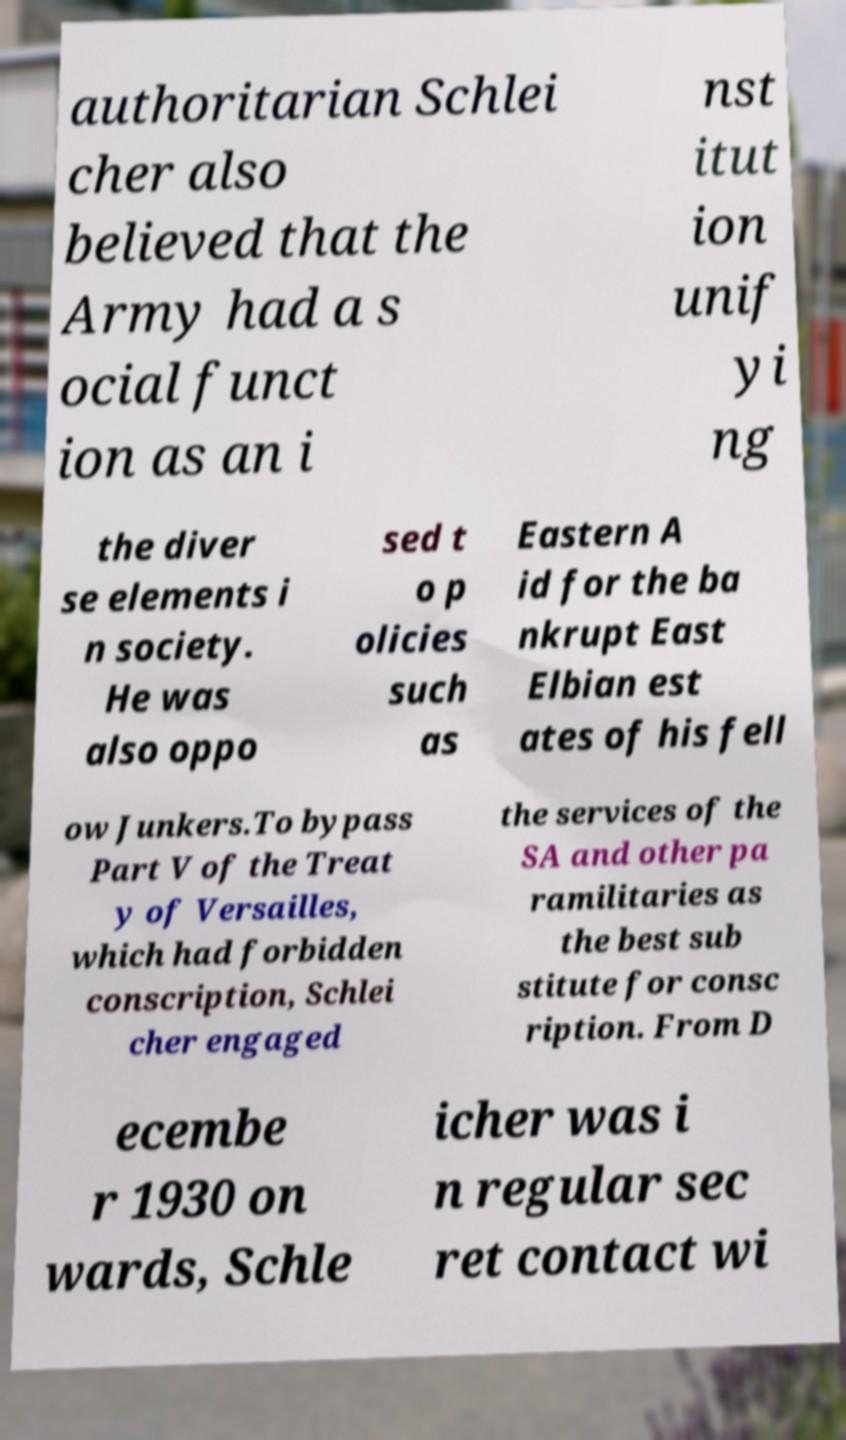There's text embedded in this image that I need extracted. Can you transcribe it verbatim? authoritarian Schlei cher also believed that the Army had a s ocial funct ion as an i nst itut ion unif yi ng the diver se elements i n society. He was also oppo sed t o p olicies such as Eastern A id for the ba nkrupt East Elbian est ates of his fell ow Junkers.To bypass Part V of the Treat y of Versailles, which had forbidden conscription, Schlei cher engaged the services of the SA and other pa ramilitaries as the best sub stitute for consc ription. From D ecembe r 1930 on wards, Schle icher was i n regular sec ret contact wi 